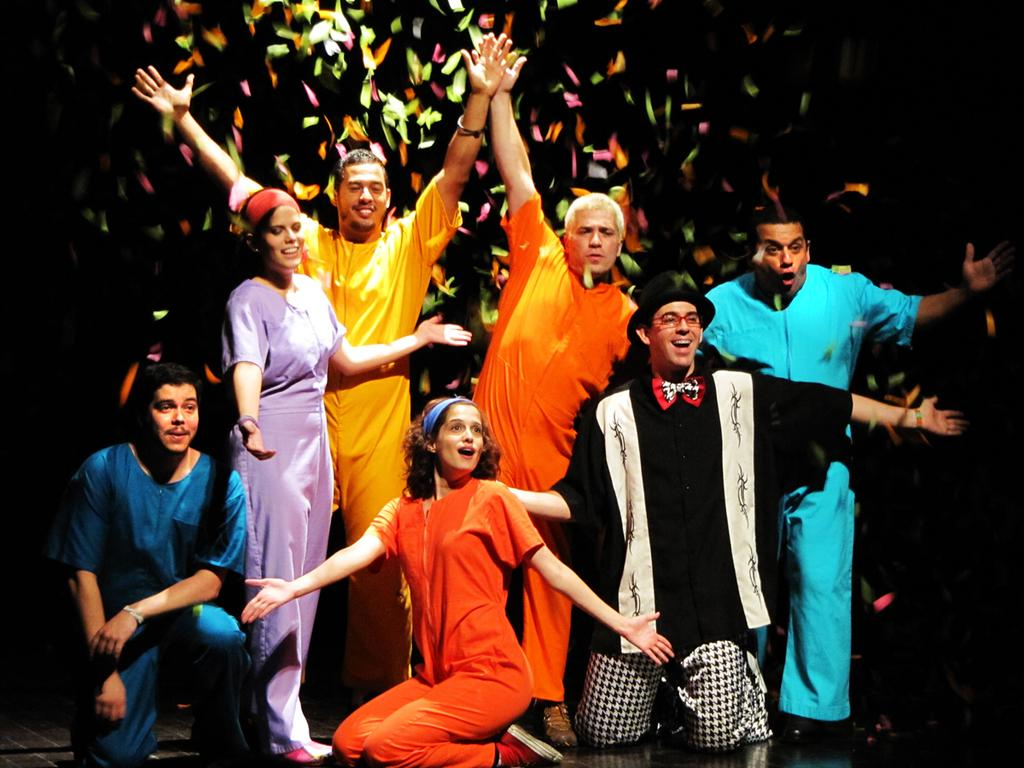What are the people in the image doing? The people in the image are standing and some are seated on their knees. Can you describe the appearance of one of the individuals in the image? There is a man wearing a cap in the image. What type of objects can be seen in the image besides people? Colorful papers are visible in the image. What type of ball is being used in the game depicted in the image? There is no ball or game present in the image; it features people standing and seated on their knees, as well as colorful papers. Can you tell me how many corks are visible in the image? There are no corks visible in the image. 